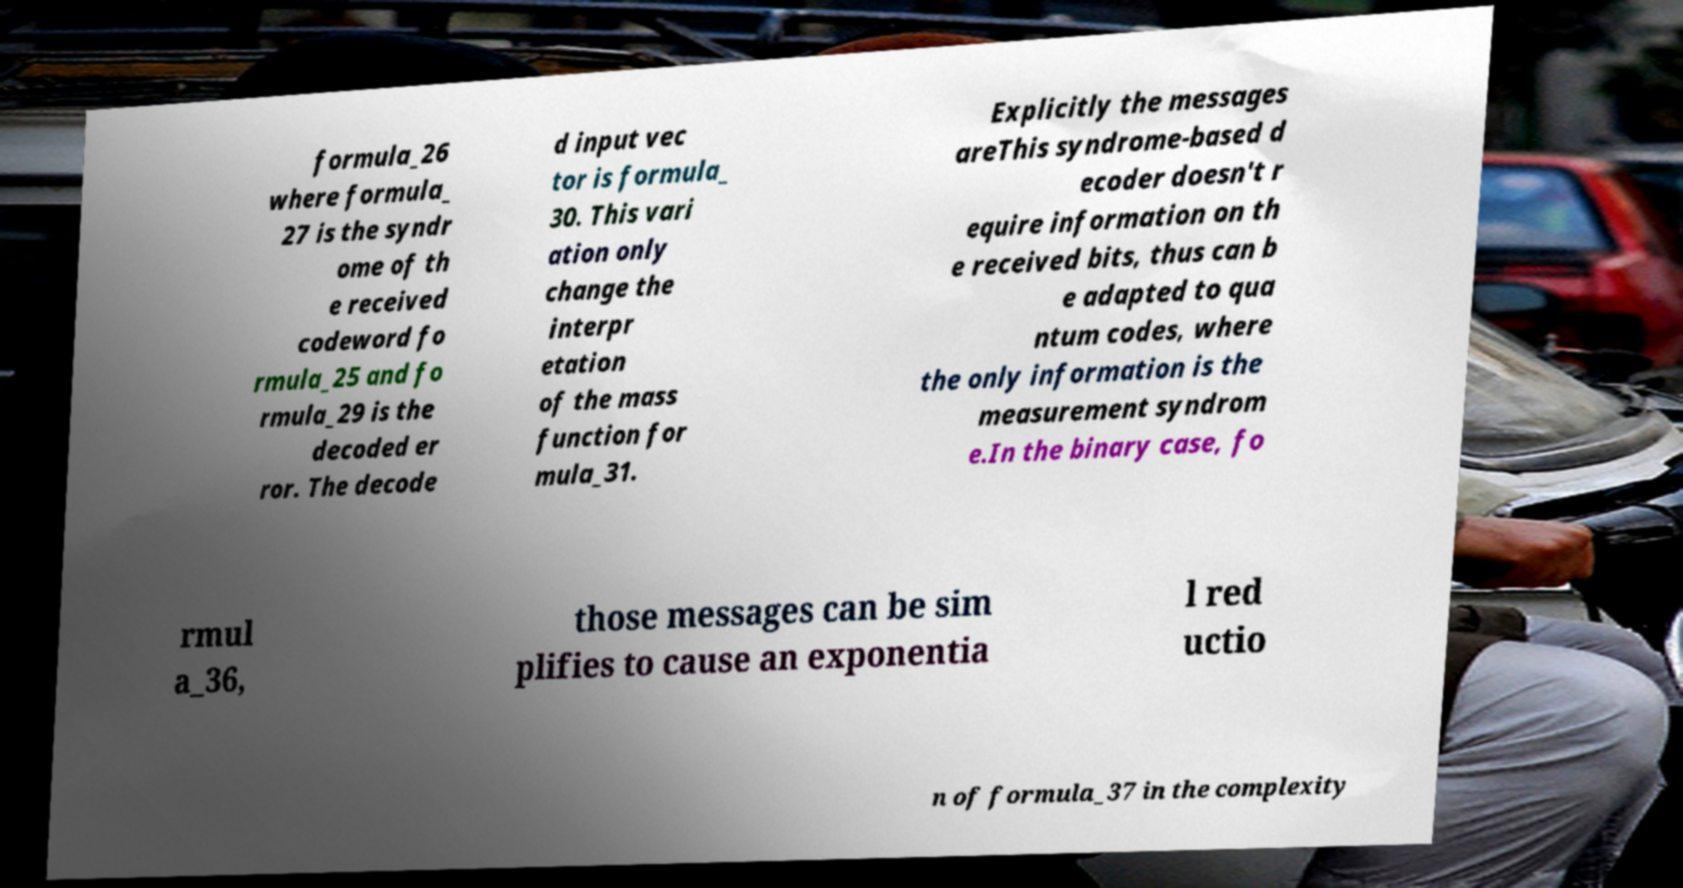Can you accurately transcribe the text from the provided image for me? formula_26 where formula_ 27 is the syndr ome of th e received codeword fo rmula_25 and fo rmula_29 is the decoded er ror. The decode d input vec tor is formula_ 30. This vari ation only change the interpr etation of the mass function for mula_31. Explicitly the messages areThis syndrome-based d ecoder doesn't r equire information on th e received bits, thus can b e adapted to qua ntum codes, where the only information is the measurement syndrom e.In the binary case, fo rmul a_36, those messages can be sim plifies to cause an exponentia l red uctio n of formula_37 in the complexity 